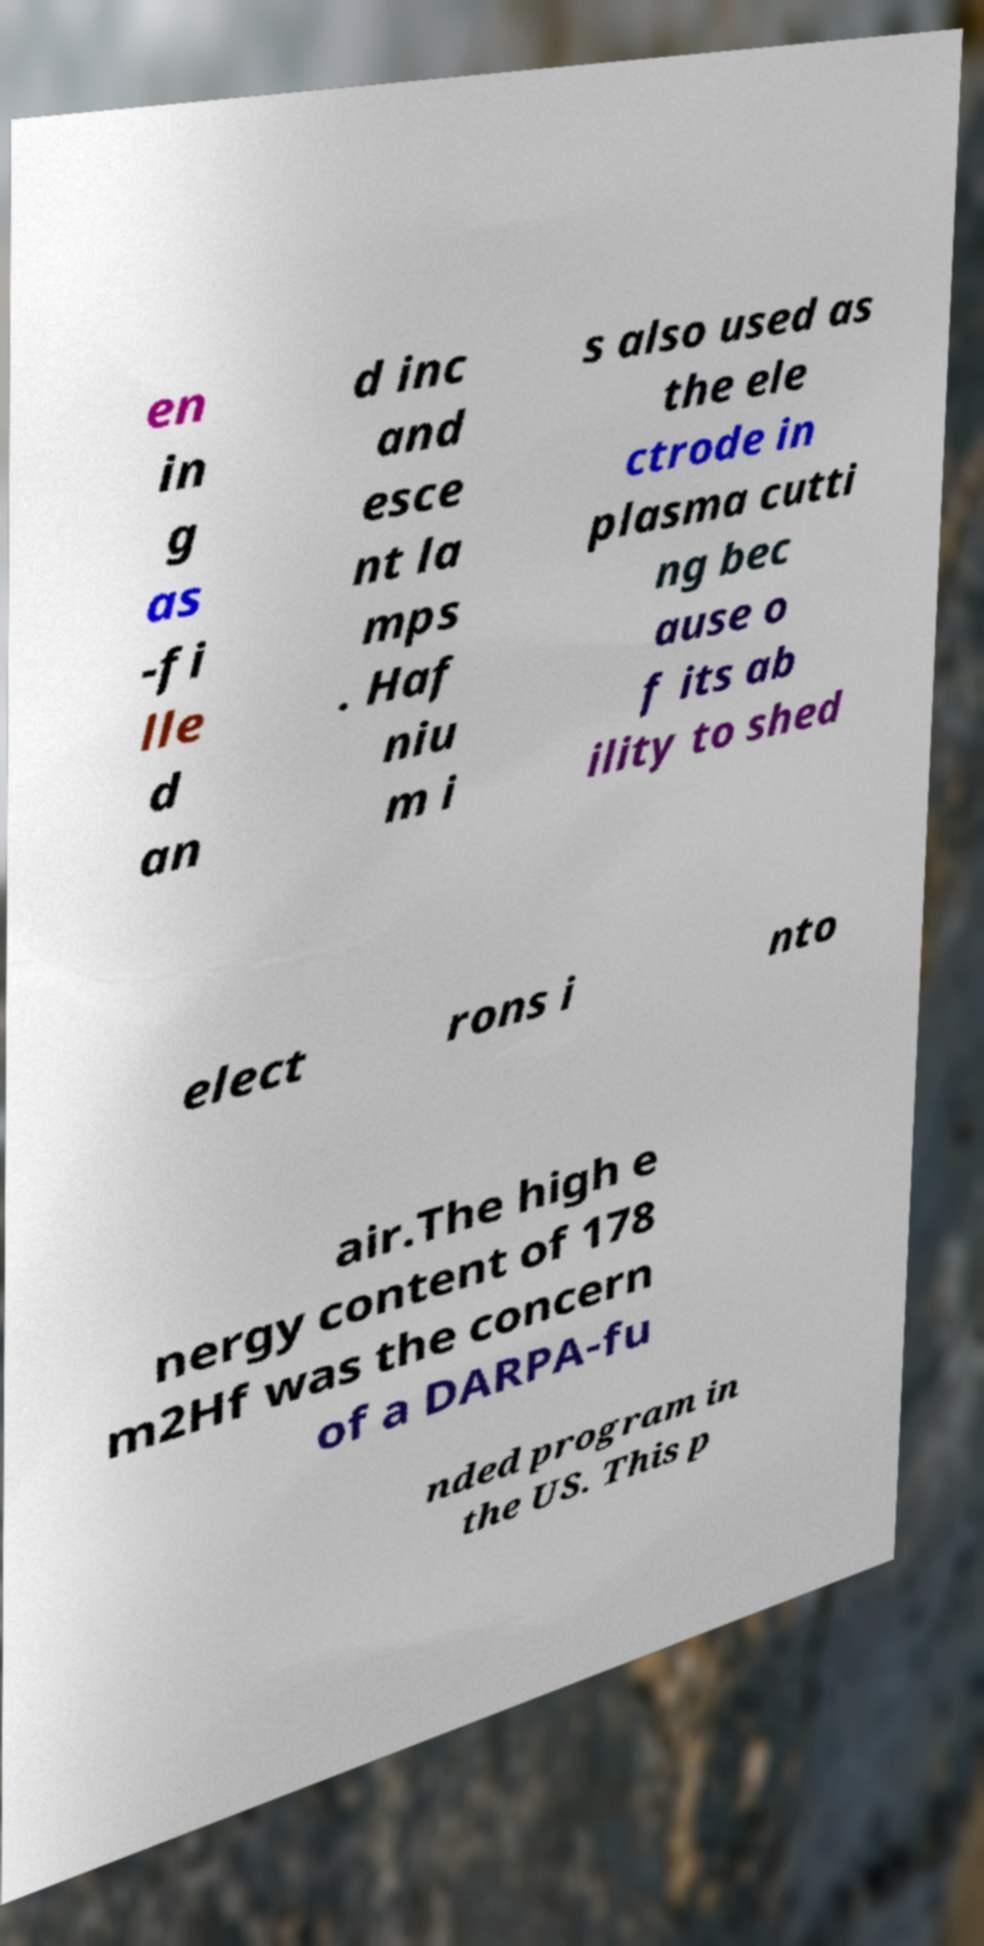Can you read and provide the text displayed in the image?This photo seems to have some interesting text. Can you extract and type it out for me? en in g as -fi lle d an d inc and esce nt la mps . Haf niu m i s also used as the ele ctrode in plasma cutti ng bec ause o f its ab ility to shed elect rons i nto air.The high e nergy content of 178 m2Hf was the concern of a DARPA-fu nded program in the US. This p 